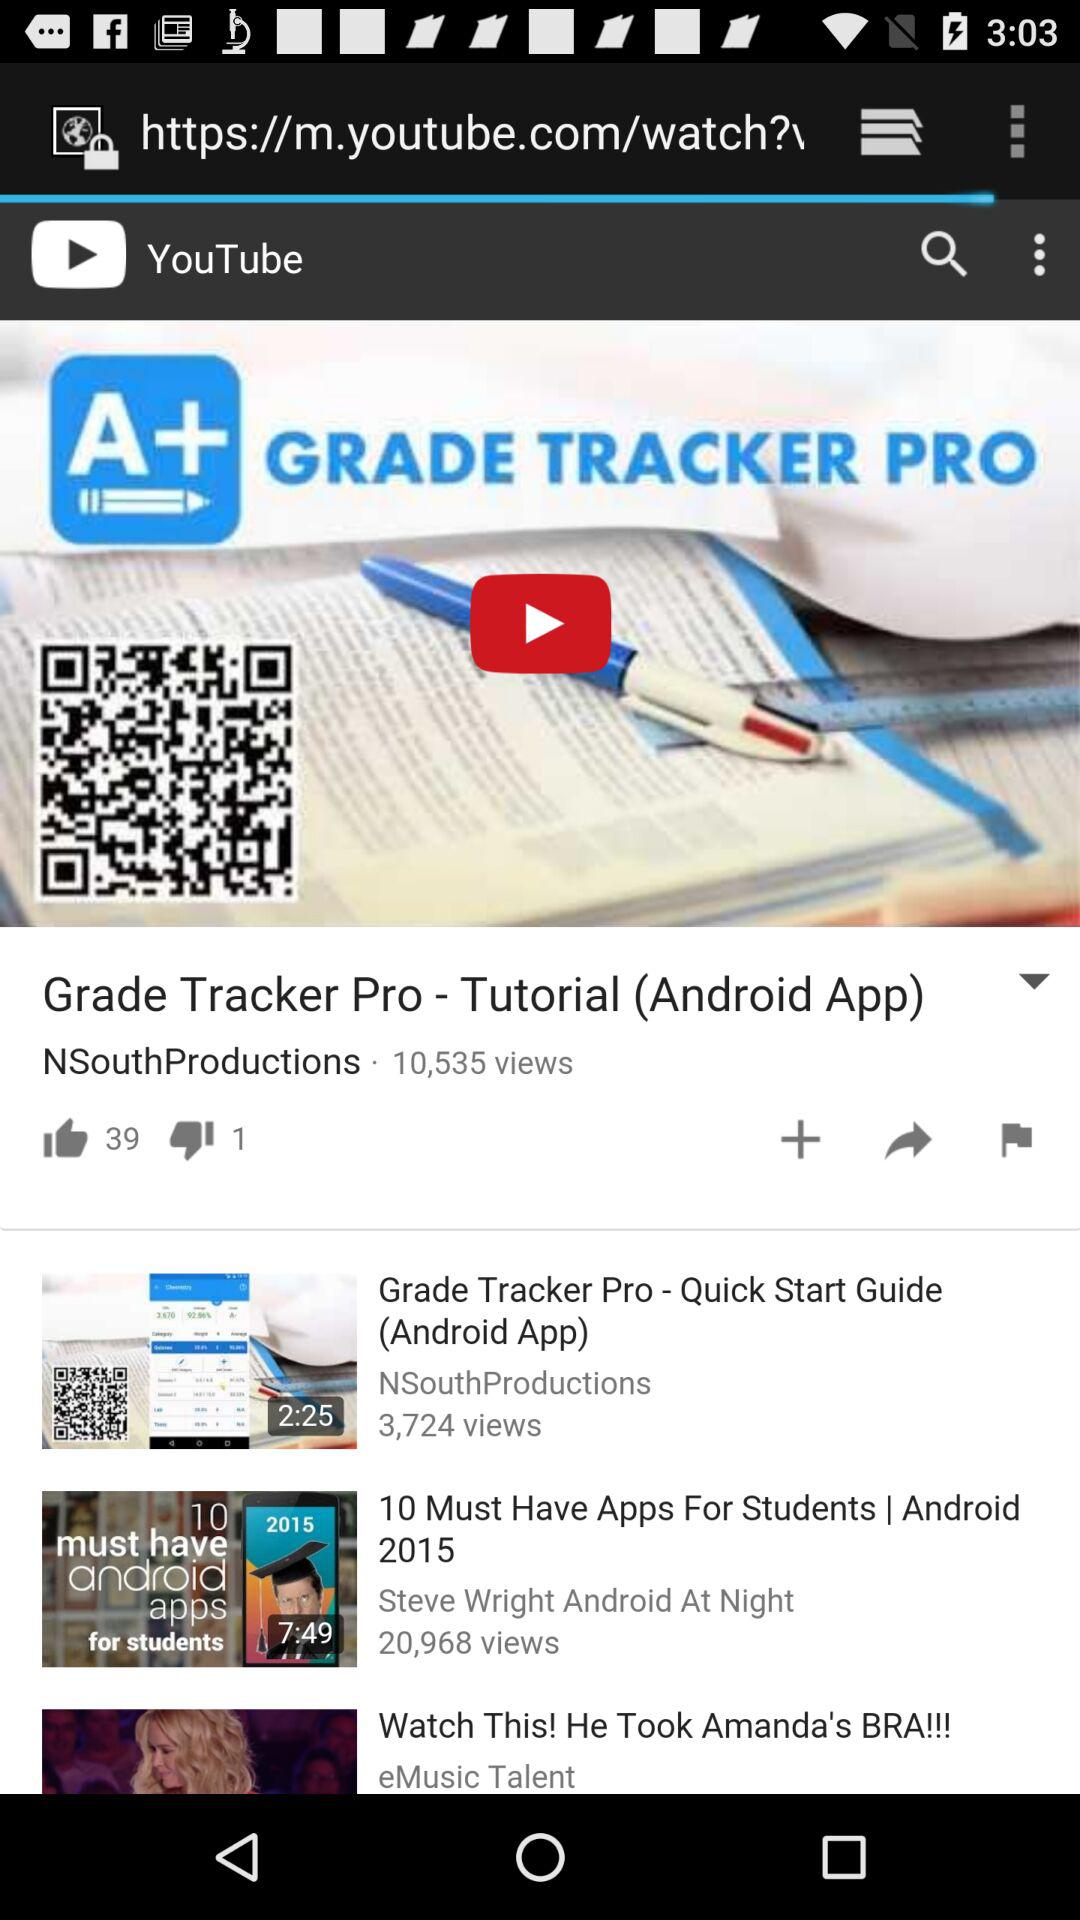How many thumbs up does the top video have?
Answer the question using a single word or phrase. 39 